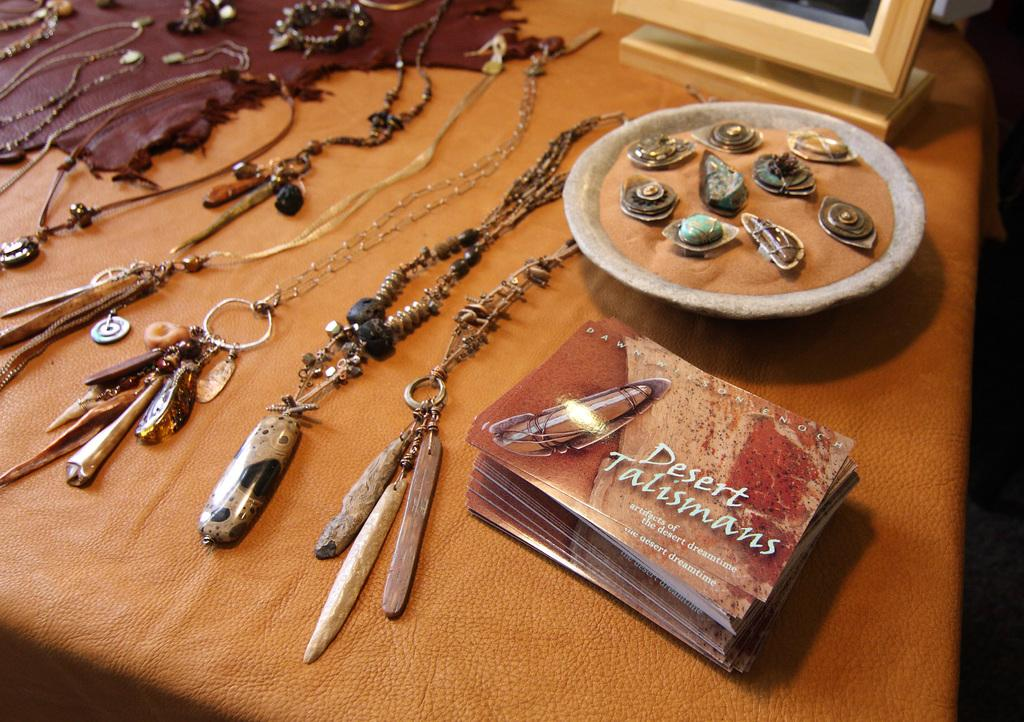<image>
Describe the image concisely. Variety of jewelry with the business card for Desert Talismans 